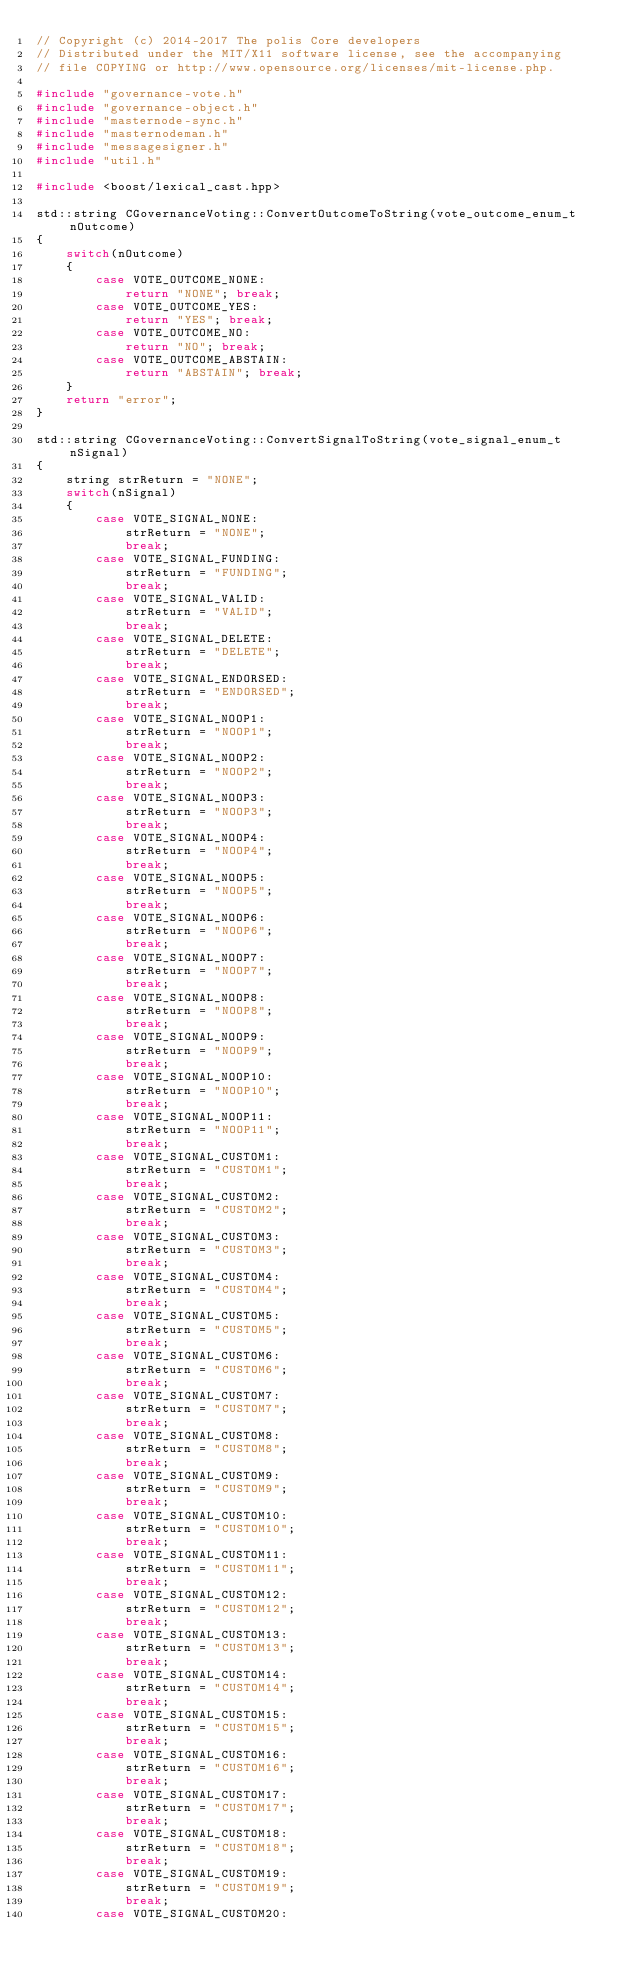<code> <loc_0><loc_0><loc_500><loc_500><_C++_>// Copyright (c) 2014-2017 The polis Core developers
// Distributed under the MIT/X11 software license, see the accompanying
// file COPYING or http://www.opensource.org/licenses/mit-license.php.

#include "governance-vote.h"
#include "governance-object.h"
#include "masternode-sync.h"
#include "masternodeman.h"
#include "messagesigner.h"
#include "util.h"

#include <boost/lexical_cast.hpp>

std::string CGovernanceVoting::ConvertOutcomeToString(vote_outcome_enum_t nOutcome)
{
    switch(nOutcome)
    {
        case VOTE_OUTCOME_NONE:
            return "NONE"; break;
        case VOTE_OUTCOME_YES:
            return "YES"; break;
        case VOTE_OUTCOME_NO:
            return "NO"; break;
        case VOTE_OUTCOME_ABSTAIN:
            return "ABSTAIN"; break;
    }
    return "error";
}

std::string CGovernanceVoting::ConvertSignalToString(vote_signal_enum_t nSignal)
{
    string strReturn = "NONE";
    switch(nSignal)
    {
        case VOTE_SIGNAL_NONE:
            strReturn = "NONE";
            break;
        case VOTE_SIGNAL_FUNDING:
            strReturn = "FUNDING";
            break;
        case VOTE_SIGNAL_VALID:
            strReturn = "VALID";
            break;
        case VOTE_SIGNAL_DELETE:
            strReturn = "DELETE";
            break;
        case VOTE_SIGNAL_ENDORSED:
            strReturn = "ENDORSED";
            break;
        case VOTE_SIGNAL_NOOP1:
            strReturn = "NOOP1";
            break;
        case VOTE_SIGNAL_NOOP2:
            strReturn = "NOOP2";
            break;
        case VOTE_SIGNAL_NOOP3:
            strReturn = "NOOP3";
            break;
        case VOTE_SIGNAL_NOOP4:
            strReturn = "NOOP4";
            break;
        case VOTE_SIGNAL_NOOP5:
            strReturn = "NOOP5";
            break;
        case VOTE_SIGNAL_NOOP6:
            strReturn = "NOOP6";
            break;
        case VOTE_SIGNAL_NOOP7:
            strReturn = "NOOP7";
            break;
        case VOTE_SIGNAL_NOOP8:
            strReturn = "NOOP8";
            break;
        case VOTE_SIGNAL_NOOP9:
            strReturn = "NOOP9";
            break;
        case VOTE_SIGNAL_NOOP10:
            strReturn = "NOOP10";
            break;
        case VOTE_SIGNAL_NOOP11:
            strReturn = "NOOP11";
            break;
        case VOTE_SIGNAL_CUSTOM1:
            strReturn = "CUSTOM1";
            break;
        case VOTE_SIGNAL_CUSTOM2:
            strReturn = "CUSTOM2";
            break;
        case VOTE_SIGNAL_CUSTOM3:
            strReturn = "CUSTOM3";
            break;
        case VOTE_SIGNAL_CUSTOM4:
            strReturn = "CUSTOM4";
            break;
        case VOTE_SIGNAL_CUSTOM5:
            strReturn = "CUSTOM5";
            break;
        case VOTE_SIGNAL_CUSTOM6:
            strReturn = "CUSTOM6";
            break;
        case VOTE_SIGNAL_CUSTOM7:
            strReturn = "CUSTOM7";
            break;
        case VOTE_SIGNAL_CUSTOM8:
            strReturn = "CUSTOM8";
            break;
        case VOTE_SIGNAL_CUSTOM9:
            strReturn = "CUSTOM9";
            break;
        case VOTE_SIGNAL_CUSTOM10:
            strReturn = "CUSTOM10";
            break;
        case VOTE_SIGNAL_CUSTOM11:
            strReturn = "CUSTOM11";
            break;
        case VOTE_SIGNAL_CUSTOM12:
            strReturn = "CUSTOM12";
            break;
        case VOTE_SIGNAL_CUSTOM13:
            strReturn = "CUSTOM13";
            break;
        case VOTE_SIGNAL_CUSTOM14:
            strReturn = "CUSTOM14";
            break;
        case VOTE_SIGNAL_CUSTOM15:
            strReturn = "CUSTOM15";
            break;
        case VOTE_SIGNAL_CUSTOM16:
            strReturn = "CUSTOM16";
            break;
        case VOTE_SIGNAL_CUSTOM17:
            strReturn = "CUSTOM17";
            break;
        case VOTE_SIGNAL_CUSTOM18:
            strReturn = "CUSTOM18";
            break;
        case VOTE_SIGNAL_CUSTOM19:
            strReturn = "CUSTOM19";
            break;
        case VOTE_SIGNAL_CUSTOM20:</code> 